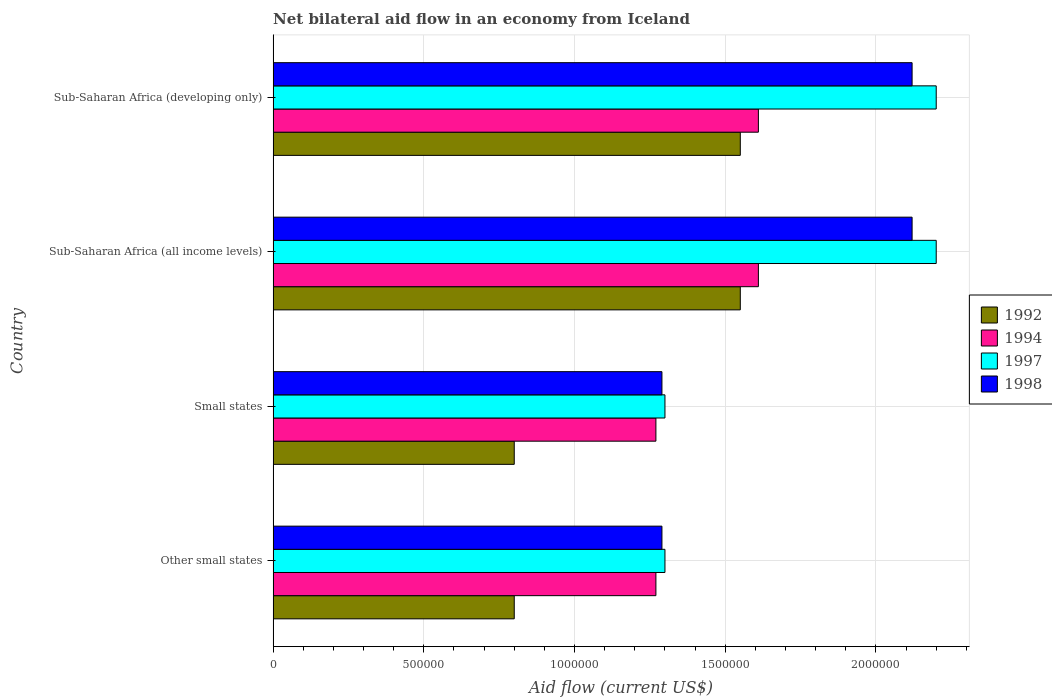Are the number of bars on each tick of the Y-axis equal?
Offer a terse response. Yes. How many bars are there on the 2nd tick from the bottom?
Offer a very short reply. 4. What is the label of the 1st group of bars from the top?
Provide a short and direct response. Sub-Saharan Africa (developing only). What is the net bilateral aid flow in 1994 in Sub-Saharan Africa (all income levels)?
Offer a very short reply. 1.61e+06. Across all countries, what is the maximum net bilateral aid flow in 1998?
Offer a very short reply. 2.12e+06. Across all countries, what is the minimum net bilateral aid flow in 1998?
Ensure brevity in your answer.  1.29e+06. In which country was the net bilateral aid flow in 1994 maximum?
Offer a very short reply. Sub-Saharan Africa (all income levels). In which country was the net bilateral aid flow in 1992 minimum?
Give a very brief answer. Other small states. What is the total net bilateral aid flow in 1992 in the graph?
Your answer should be very brief. 4.70e+06. What is the difference between the net bilateral aid flow in 1992 in Other small states and that in Sub-Saharan Africa (developing only)?
Offer a terse response. -7.50e+05. What is the difference between the net bilateral aid flow in 1994 in Sub-Saharan Africa (all income levels) and the net bilateral aid flow in 1998 in Other small states?
Ensure brevity in your answer.  3.20e+05. What is the average net bilateral aid flow in 1997 per country?
Ensure brevity in your answer.  1.75e+06. What is the difference between the net bilateral aid flow in 1994 and net bilateral aid flow in 1998 in Sub-Saharan Africa (developing only)?
Keep it short and to the point. -5.10e+05. What is the ratio of the net bilateral aid flow in 1992 in Small states to that in Sub-Saharan Africa (developing only)?
Offer a very short reply. 0.52. Is the net bilateral aid flow in 1998 in Small states less than that in Sub-Saharan Africa (developing only)?
Provide a short and direct response. Yes. Is the difference between the net bilateral aid flow in 1994 in Small states and Sub-Saharan Africa (developing only) greater than the difference between the net bilateral aid flow in 1998 in Small states and Sub-Saharan Africa (developing only)?
Your answer should be compact. Yes. What is the difference between the highest and the second highest net bilateral aid flow in 1994?
Provide a short and direct response. 0. What is the difference between the highest and the lowest net bilateral aid flow in 1998?
Provide a succinct answer. 8.30e+05. In how many countries, is the net bilateral aid flow in 1992 greater than the average net bilateral aid flow in 1992 taken over all countries?
Your answer should be very brief. 2. Is the sum of the net bilateral aid flow in 1992 in Small states and Sub-Saharan Africa (all income levels) greater than the maximum net bilateral aid flow in 1998 across all countries?
Provide a short and direct response. Yes. Is it the case that in every country, the sum of the net bilateral aid flow in 1992 and net bilateral aid flow in 1998 is greater than the sum of net bilateral aid flow in 1994 and net bilateral aid flow in 1997?
Your answer should be compact. No. What does the 2nd bar from the top in Other small states represents?
Give a very brief answer. 1997. What does the 2nd bar from the bottom in Sub-Saharan Africa (all income levels) represents?
Provide a short and direct response. 1994. Is it the case that in every country, the sum of the net bilateral aid flow in 1994 and net bilateral aid flow in 1992 is greater than the net bilateral aid flow in 1997?
Offer a very short reply. Yes. How many bars are there?
Your answer should be very brief. 16. Are all the bars in the graph horizontal?
Your answer should be very brief. Yes. How many countries are there in the graph?
Ensure brevity in your answer.  4. What is the difference between two consecutive major ticks on the X-axis?
Your answer should be compact. 5.00e+05. Does the graph contain grids?
Offer a very short reply. Yes. Where does the legend appear in the graph?
Your answer should be compact. Center right. How many legend labels are there?
Your answer should be compact. 4. How are the legend labels stacked?
Keep it short and to the point. Vertical. What is the title of the graph?
Offer a very short reply. Net bilateral aid flow in an economy from Iceland. What is the Aid flow (current US$) of 1994 in Other small states?
Your response must be concise. 1.27e+06. What is the Aid flow (current US$) in 1997 in Other small states?
Offer a very short reply. 1.30e+06. What is the Aid flow (current US$) in 1998 in Other small states?
Provide a succinct answer. 1.29e+06. What is the Aid flow (current US$) of 1992 in Small states?
Keep it short and to the point. 8.00e+05. What is the Aid flow (current US$) in 1994 in Small states?
Provide a succinct answer. 1.27e+06. What is the Aid flow (current US$) in 1997 in Small states?
Ensure brevity in your answer.  1.30e+06. What is the Aid flow (current US$) in 1998 in Small states?
Make the answer very short. 1.29e+06. What is the Aid flow (current US$) in 1992 in Sub-Saharan Africa (all income levels)?
Provide a short and direct response. 1.55e+06. What is the Aid flow (current US$) in 1994 in Sub-Saharan Africa (all income levels)?
Keep it short and to the point. 1.61e+06. What is the Aid flow (current US$) of 1997 in Sub-Saharan Africa (all income levels)?
Offer a terse response. 2.20e+06. What is the Aid flow (current US$) in 1998 in Sub-Saharan Africa (all income levels)?
Make the answer very short. 2.12e+06. What is the Aid flow (current US$) of 1992 in Sub-Saharan Africa (developing only)?
Your answer should be compact. 1.55e+06. What is the Aid flow (current US$) of 1994 in Sub-Saharan Africa (developing only)?
Make the answer very short. 1.61e+06. What is the Aid flow (current US$) of 1997 in Sub-Saharan Africa (developing only)?
Your response must be concise. 2.20e+06. What is the Aid flow (current US$) of 1998 in Sub-Saharan Africa (developing only)?
Your answer should be compact. 2.12e+06. Across all countries, what is the maximum Aid flow (current US$) of 1992?
Offer a terse response. 1.55e+06. Across all countries, what is the maximum Aid flow (current US$) of 1994?
Provide a short and direct response. 1.61e+06. Across all countries, what is the maximum Aid flow (current US$) in 1997?
Ensure brevity in your answer.  2.20e+06. Across all countries, what is the maximum Aid flow (current US$) in 1998?
Ensure brevity in your answer.  2.12e+06. Across all countries, what is the minimum Aid flow (current US$) in 1992?
Make the answer very short. 8.00e+05. Across all countries, what is the minimum Aid flow (current US$) of 1994?
Your response must be concise. 1.27e+06. Across all countries, what is the minimum Aid flow (current US$) in 1997?
Your answer should be very brief. 1.30e+06. Across all countries, what is the minimum Aid flow (current US$) of 1998?
Provide a short and direct response. 1.29e+06. What is the total Aid flow (current US$) of 1992 in the graph?
Ensure brevity in your answer.  4.70e+06. What is the total Aid flow (current US$) of 1994 in the graph?
Your answer should be compact. 5.76e+06. What is the total Aid flow (current US$) in 1997 in the graph?
Your answer should be compact. 7.00e+06. What is the total Aid flow (current US$) in 1998 in the graph?
Your response must be concise. 6.82e+06. What is the difference between the Aid flow (current US$) in 1994 in Other small states and that in Small states?
Your response must be concise. 0. What is the difference between the Aid flow (current US$) of 1997 in Other small states and that in Small states?
Your response must be concise. 0. What is the difference between the Aid flow (current US$) in 1992 in Other small states and that in Sub-Saharan Africa (all income levels)?
Offer a very short reply. -7.50e+05. What is the difference between the Aid flow (current US$) in 1994 in Other small states and that in Sub-Saharan Africa (all income levels)?
Offer a very short reply. -3.40e+05. What is the difference between the Aid flow (current US$) of 1997 in Other small states and that in Sub-Saharan Africa (all income levels)?
Provide a succinct answer. -9.00e+05. What is the difference between the Aid flow (current US$) in 1998 in Other small states and that in Sub-Saharan Africa (all income levels)?
Provide a short and direct response. -8.30e+05. What is the difference between the Aid flow (current US$) in 1992 in Other small states and that in Sub-Saharan Africa (developing only)?
Provide a succinct answer. -7.50e+05. What is the difference between the Aid flow (current US$) of 1994 in Other small states and that in Sub-Saharan Africa (developing only)?
Make the answer very short. -3.40e+05. What is the difference between the Aid flow (current US$) of 1997 in Other small states and that in Sub-Saharan Africa (developing only)?
Keep it short and to the point. -9.00e+05. What is the difference between the Aid flow (current US$) of 1998 in Other small states and that in Sub-Saharan Africa (developing only)?
Your response must be concise. -8.30e+05. What is the difference between the Aid flow (current US$) of 1992 in Small states and that in Sub-Saharan Africa (all income levels)?
Your answer should be very brief. -7.50e+05. What is the difference between the Aid flow (current US$) of 1997 in Small states and that in Sub-Saharan Africa (all income levels)?
Ensure brevity in your answer.  -9.00e+05. What is the difference between the Aid flow (current US$) in 1998 in Small states and that in Sub-Saharan Africa (all income levels)?
Keep it short and to the point. -8.30e+05. What is the difference between the Aid flow (current US$) in 1992 in Small states and that in Sub-Saharan Africa (developing only)?
Give a very brief answer. -7.50e+05. What is the difference between the Aid flow (current US$) of 1997 in Small states and that in Sub-Saharan Africa (developing only)?
Make the answer very short. -9.00e+05. What is the difference between the Aid flow (current US$) of 1998 in Small states and that in Sub-Saharan Africa (developing only)?
Give a very brief answer. -8.30e+05. What is the difference between the Aid flow (current US$) in 1994 in Sub-Saharan Africa (all income levels) and that in Sub-Saharan Africa (developing only)?
Your answer should be compact. 0. What is the difference between the Aid flow (current US$) in 1997 in Sub-Saharan Africa (all income levels) and that in Sub-Saharan Africa (developing only)?
Make the answer very short. 0. What is the difference between the Aid flow (current US$) of 1998 in Sub-Saharan Africa (all income levels) and that in Sub-Saharan Africa (developing only)?
Make the answer very short. 0. What is the difference between the Aid flow (current US$) of 1992 in Other small states and the Aid flow (current US$) of 1994 in Small states?
Provide a short and direct response. -4.70e+05. What is the difference between the Aid flow (current US$) of 1992 in Other small states and the Aid flow (current US$) of 1997 in Small states?
Keep it short and to the point. -5.00e+05. What is the difference between the Aid flow (current US$) in 1992 in Other small states and the Aid flow (current US$) in 1998 in Small states?
Provide a succinct answer. -4.90e+05. What is the difference between the Aid flow (current US$) in 1997 in Other small states and the Aid flow (current US$) in 1998 in Small states?
Your response must be concise. 10000. What is the difference between the Aid flow (current US$) in 1992 in Other small states and the Aid flow (current US$) in 1994 in Sub-Saharan Africa (all income levels)?
Give a very brief answer. -8.10e+05. What is the difference between the Aid flow (current US$) of 1992 in Other small states and the Aid flow (current US$) of 1997 in Sub-Saharan Africa (all income levels)?
Your answer should be compact. -1.40e+06. What is the difference between the Aid flow (current US$) of 1992 in Other small states and the Aid flow (current US$) of 1998 in Sub-Saharan Africa (all income levels)?
Offer a very short reply. -1.32e+06. What is the difference between the Aid flow (current US$) in 1994 in Other small states and the Aid flow (current US$) in 1997 in Sub-Saharan Africa (all income levels)?
Give a very brief answer. -9.30e+05. What is the difference between the Aid flow (current US$) in 1994 in Other small states and the Aid flow (current US$) in 1998 in Sub-Saharan Africa (all income levels)?
Your answer should be very brief. -8.50e+05. What is the difference between the Aid flow (current US$) of 1997 in Other small states and the Aid flow (current US$) of 1998 in Sub-Saharan Africa (all income levels)?
Provide a short and direct response. -8.20e+05. What is the difference between the Aid flow (current US$) of 1992 in Other small states and the Aid flow (current US$) of 1994 in Sub-Saharan Africa (developing only)?
Offer a terse response. -8.10e+05. What is the difference between the Aid flow (current US$) in 1992 in Other small states and the Aid flow (current US$) in 1997 in Sub-Saharan Africa (developing only)?
Offer a very short reply. -1.40e+06. What is the difference between the Aid flow (current US$) of 1992 in Other small states and the Aid flow (current US$) of 1998 in Sub-Saharan Africa (developing only)?
Offer a very short reply. -1.32e+06. What is the difference between the Aid flow (current US$) in 1994 in Other small states and the Aid flow (current US$) in 1997 in Sub-Saharan Africa (developing only)?
Your answer should be compact. -9.30e+05. What is the difference between the Aid flow (current US$) of 1994 in Other small states and the Aid flow (current US$) of 1998 in Sub-Saharan Africa (developing only)?
Your answer should be compact. -8.50e+05. What is the difference between the Aid flow (current US$) of 1997 in Other small states and the Aid flow (current US$) of 1998 in Sub-Saharan Africa (developing only)?
Provide a short and direct response. -8.20e+05. What is the difference between the Aid flow (current US$) of 1992 in Small states and the Aid flow (current US$) of 1994 in Sub-Saharan Africa (all income levels)?
Provide a succinct answer. -8.10e+05. What is the difference between the Aid flow (current US$) in 1992 in Small states and the Aid flow (current US$) in 1997 in Sub-Saharan Africa (all income levels)?
Provide a succinct answer. -1.40e+06. What is the difference between the Aid flow (current US$) in 1992 in Small states and the Aid flow (current US$) in 1998 in Sub-Saharan Africa (all income levels)?
Offer a terse response. -1.32e+06. What is the difference between the Aid flow (current US$) of 1994 in Small states and the Aid flow (current US$) of 1997 in Sub-Saharan Africa (all income levels)?
Your response must be concise. -9.30e+05. What is the difference between the Aid flow (current US$) of 1994 in Small states and the Aid flow (current US$) of 1998 in Sub-Saharan Africa (all income levels)?
Ensure brevity in your answer.  -8.50e+05. What is the difference between the Aid flow (current US$) in 1997 in Small states and the Aid flow (current US$) in 1998 in Sub-Saharan Africa (all income levels)?
Keep it short and to the point. -8.20e+05. What is the difference between the Aid flow (current US$) in 1992 in Small states and the Aid flow (current US$) in 1994 in Sub-Saharan Africa (developing only)?
Your answer should be compact. -8.10e+05. What is the difference between the Aid flow (current US$) in 1992 in Small states and the Aid flow (current US$) in 1997 in Sub-Saharan Africa (developing only)?
Provide a succinct answer. -1.40e+06. What is the difference between the Aid flow (current US$) of 1992 in Small states and the Aid flow (current US$) of 1998 in Sub-Saharan Africa (developing only)?
Your answer should be very brief. -1.32e+06. What is the difference between the Aid flow (current US$) of 1994 in Small states and the Aid flow (current US$) of 1997 in Sub-Saharan Africa (developing only)?
Provide a short and direct response. -9.30e+05. What is the difference between the Aid flow (current US$) in 1994 in Small states and the Aid flow (current US$) in 1998 in Sub-Saharan Africa (developing only)?
Your answer should be compact. -8.50e+05. What is the difference between the Aid flow (current US$) in 1997 in Small states and the Aid flow (current US$) in 1998 in Sub-Saharan Africa (developing only)?
Offer a very short reply. -8.20e+05. What is the difference between the Aid flow (current US$) of 1992 in Sub-Saharan Africa (all income levels) and the Aid flow (current US$) of 1997 in Sub-Saharan Africa (developing only)?
Your answer should be compact. -6.50e+05. What is the difference between the Aid flow (current US$) of 1992 in Sub-Saharan Africa (all income levels) and the Aid flow (current US$) of 1998 in Sub-Saharan Africa (developing only)?
Provide a short and direct response. -5.70e+05. What is the difference between the Aid flow (current US$) of 1994 in Sub-Saharan Africa (all income levels) and the Aid flow (current US$) of 1997 in Sub-Saharan Africa (developing only)?
Keep it short and to the point. -5.90e+05. What is the difference between the Aid flow (current US$) of 1994 in Sub-Saharan Africa (all income levels) and the Aid flow (current US$) of 1998 in Sub-Saharan Africa (developing only)?
Your response must be concise. -5.10e+05. What is the average Aid flow (current US$) in 1992 per country?
Your response must be concise. 1.18e+06. What is the average Aid flow (current US$) in 1994 per country?
Provide a succinct answer. 1.44e+06. What is the average Aid flow (current US$) of 1997 per country?
Offer a terse response. 1.75e+06. What is the average Aid flow (current US$) of 1998 per country?
Ensure brevity in your answer.  1.70e+06. What is the difference between the Aid flow (current US$) in 1992 and Aid flow (current US$) in 1994 in Other small states?
Provide a succinct answer. -4.70e+05. What is the difference between the Aid flow (current US$) of 1992 and Aid flow (current US$) of 1997 in Other small states?
Your answer should be compact. -5.00e+05. What is the difference between the Aid flow (current US$) of 1992 and Aid flow (current US$) of 1998 in Other small states?
Give a very brief answer. -4.90e+05. What is the difference between the Aid flow (current US$) of 1994 and Aid flow (current US$) of 1998 in Other small states?
Make the answer very short. -2.00e+04. What is the difference between the Aid flow (current US$) of 1992 and Aid flow (current US$) of 1994 in Small states?
Provide a succinct answer. -4.70e+05. What is the difference between the Aid flow (current US$) of 1992 and Aid flow (current US$) of 1997 in Small states?
Offer a very short reply. -5.00e+05. What is the difference between the Aid flow (current US$) of 1992 and Aid flow (current US$) of 1998 in Small states?
Ensure brevity in your answer.  -4.90e+05. What is the difference between the Aid flow (current US$) of 1997 and Aid flow (current US$) of 1998 in Small states?
Provide a short and direct response. 10000. What is the difference between the Aid flow (current US$) in 1992 and Aid flow (current US$) in 1994 in Sub-Saharan Africa (all income levels)?
Provide a succinct answer. -6.00e+04. What is the difference between the Aid flow (current US$) of 1992 and Aid flow (current US$) of 1997 in Sub-Saharan Africa (all income levels)?
Keep it short and to the point. -6.50e+05. What is the difference between the Aid flow (current US$) in 1992 and Aid flow (current US$) in 1998 in Sub-Saharan Africa (all income levels)?
Keep it short and to the point. -5.70e+05. What is the difference between the Aid flow (current US$) of 1994 and Aid flow (current US$) of 1997 in Sub-Saharan Africa (all income levels)?
Your answer should be compact. -5.90e+05. What is the difference between the Aid flow (current US$) in 1994 and Aid flow (current US$) in 1998 in Sub-Saharan Africa (all income levels)?
Your answer should be very brief. -5.10e+05. What is the difference between the Aid flow (current US$) in 1997 and Aid flow (current US$) in 1998 in Sub-Saharan Africa (all income levels)?
Keep it short and to the point. 8.00e+04. What is the difference between the Aid flow (current US$) of 1992 and Aid flow (current US$) of 1997 in Sub-Saharan Africa (developing only)?
Provide a short and direct response. -6.50e+05. What is the difference between the Aid flow (current US$) in 1992 and Aid flow (current US$) in 1998 in Sub-Saharan Africa (developing only)?
Ensure brevity in your answer.  -5.70e+05. What is the difference between the Aid flow (current US$) in 1994 and Aid flow (current US$) in 1997 in Sub-Saharan Africa (developing only)?
Your response must be concise. -5.90e+05. What is the difference between the Aid flow (current US$) in 1994 and Aid flow (current US$) in 1998 in Sub-Saharan Africa (developing only)?
Keep it short and to the point. -5.10e+05. What is the ratio of the Aid flow (current US$) of 1994 in Other small states to that in Small states?
Offer a very short reply. 1. What is the ratio of the Aid flow (current US$) in 1998 in Other small states to that in Small states?
Your response must be concise. 1. What is the ratio of the Aid flow (current US$) of 1992 in Other small states to that in Sub-Saharan Africa (all income levels)?
Your answer should be compact. 0.52. What is the ratio of the Aid flow (current US$) in 1994 in Other small states to that in Sub-Saharan Africa (all income levels)?
Offer a very short reply. 0.79. What is the ratio of the Aid flow (current US$) of 1997 in Other small states to that in Sub-Saharan Africa (all income levels)?
Your answer should be compact. 0.59. What is the ratio of the Aid flow (current US$) of 1998 in Other small states to that in Sub-Saharan Africa (all income levels)?
Your answer should be very brief. 0.61. What is the ratio of the Aid flow (current US$) in 1992 in Other small states to that in Sub-Saharan Africa (developing only)?
Provide a succinct answer. 0.52. What is the ratio of the Aid flow (current US$) of 1994 in Other small states to that in Sub-Saharan Africa (developing only)?
Your answer should be very brief. 0.79. What is the ratio of the Aid flow (current US$) of 1997 in Other small states to that in Sub-Saharan Africa (developing only)?
Make the answer very short. 0.59. What is the ratio of the Aid flow (current US$) of 1998 in Other small states to that in Sub-Saharan Africa (developing only)?
Your answer should be very brief. 0.61. What is the ratio of the Aid flow (current US$) in 1992 in Small states to that in Sub-Saharan Africa (all income levels)?
Keep it short and to the point. 0.52. What is the ratio of the Aid flow (current US$) in 1994 in Small states to that in Sub-Saharan Africa (all income levels)?
Give a very brief answer. 0.79. What is the ratio of the Aid flow (current US$) of 1997 in Small states to that in Sub-Saharan Africa (all income levels)?
Offer a terse response. 0.59. What is the ratio of the Aid flow (current US$) in 1998 in Small states to that in Sub-Saharan Africa (all income levels)?
Offer a terse response. 0.61. What is the ratio of the Aid flow (current US$) in 1992 in Small states to that in Sub-Saharan Africa (developing only)?
Offer a terse response. 0.52. What is the ratio of the Aid flow (current US$) in 1994 in Small states to that in Sub-Saharan Africa (developing only)?
Make the answer very short. 0.79. What is the ratio of the Aid flow (current US$) of 1997 in Small states to that in Sub-Saharan Africa (developing only)?
Your answer should be very brief. 0.59. What is the ratio of the Aid flow (current US$) of 1998 in Small states to that in Sub-Saharan Africa (developing only)?
Provide a short and direct response. 0.61. What is the difference between the highest and the second highest Aid flow (current US$) in 1992?
Offer a terse response. 0. What is the difference between the highest and the second highest Aid flow (current US$) in 1998?
Offer a very short reply. 0. What is the difference between the highest and the lowest Aid flow (current US$) of 1992?
Offer a terse response. 7.50e+05. What is the difference between the highest and the lowest Aid flow (current US$) in 1994?
Your answer should be compact. 3.40e+05. What is the difference between the highest and the lowest Aid flow (current US$) of 1997?
Offer a terse response. 9.00e+05. What is the difference between the highest and the lowest Aid flow (current US$) in 1998?
Your response must be concise. 8.30e+05. 